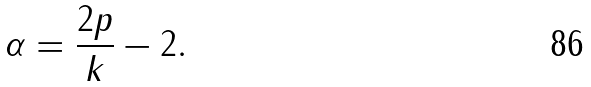<formula> <loc_0><loc_0><loc_500><loc_500>\alpha = \frac { 2 p } k - 2 .</formula> 